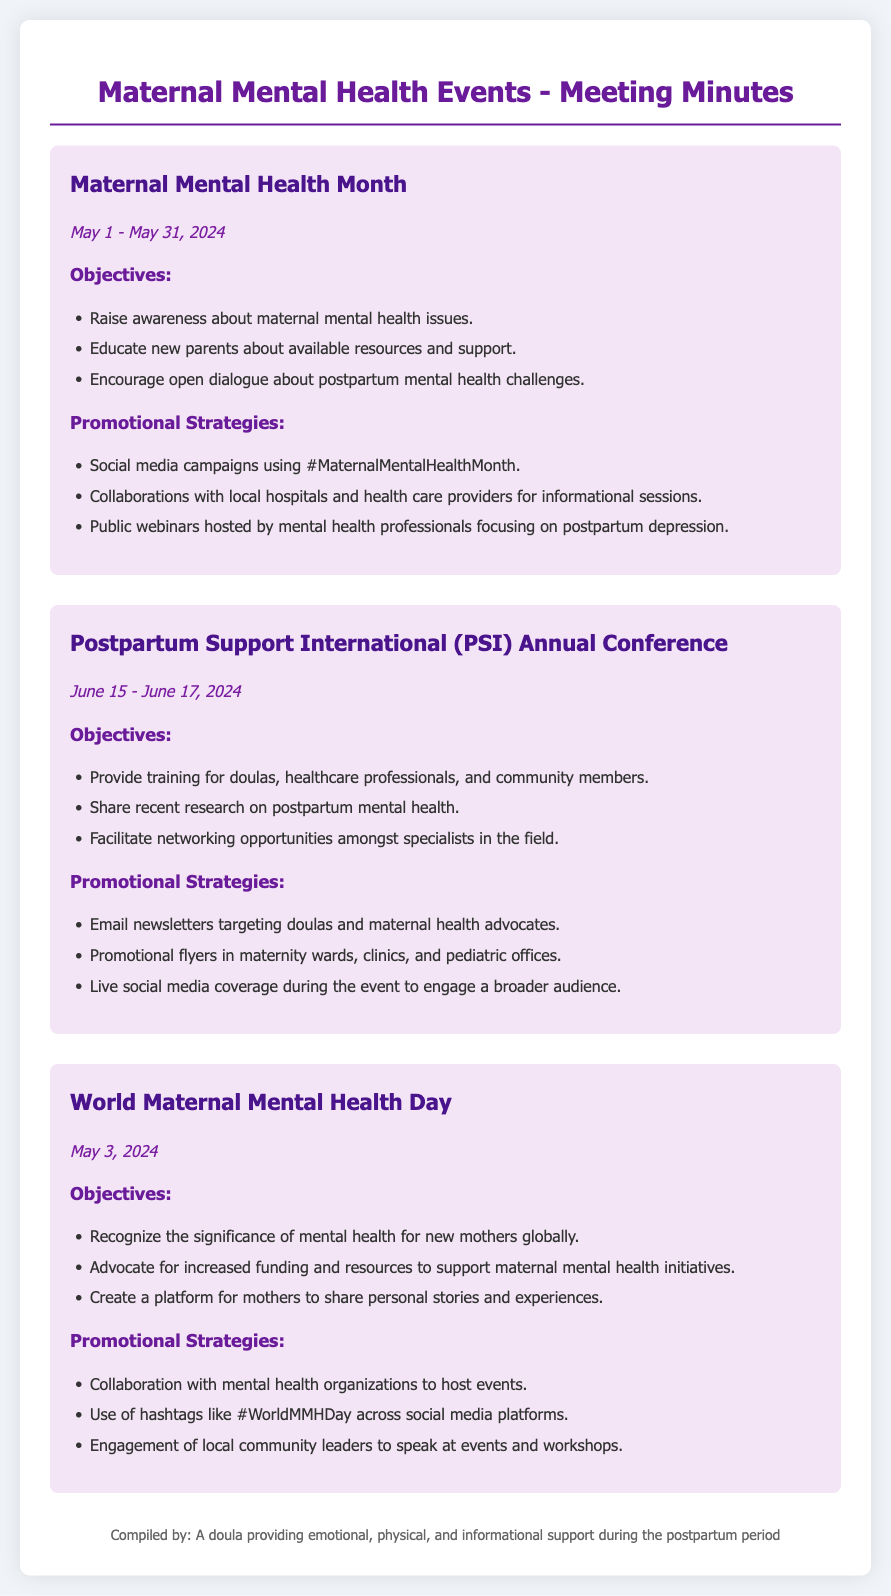what is the date range for Maternal Mental Health Month? The date range for Maternal Mental Health Month is specified in the document as May 1 - May 31, 2024.
Answer: May 1 - May 31, 2024 what is one objective of World Maternal Mental Health Day? One objective listed for World Maternal Mental Health Day is to recognize the significance of mental health for new mothers globally.
Answer: Recognize the significance of mental health for new mothers globally how many days does the PSI Annual Conference last? The PSI Annual Conference is held from June 15 to June 17, 2024, which is a total of three days.
Answer: Three days which hashtag is used for Maternal Mental Health Month? The document mentions that the hashtag used for promotional strategies during Maternal Mental Health Month is #MaternalMentalHealthMonth.
Answer: #MaternalMentalHealthMonth what type of coverage will be provided during the PSI Annual Conference? The promotional strategy includes live social media coverage during the event to engage a broader audience.
Answer: Live social media coverage what is the primary focus of the public webinars during Maternal Mental Health Month? The focus of the public webinars is on postpartum depression according to the promotional strategies detailed in the document.
Answer: Postpartum depression who compiled the meeting minutes? The document states that the minutes were compiled by "A doula providing emotional, physical, and informational support during the postpartum period."
Answer: A doula providing emotional, physical, and informational support during the postpartum period 